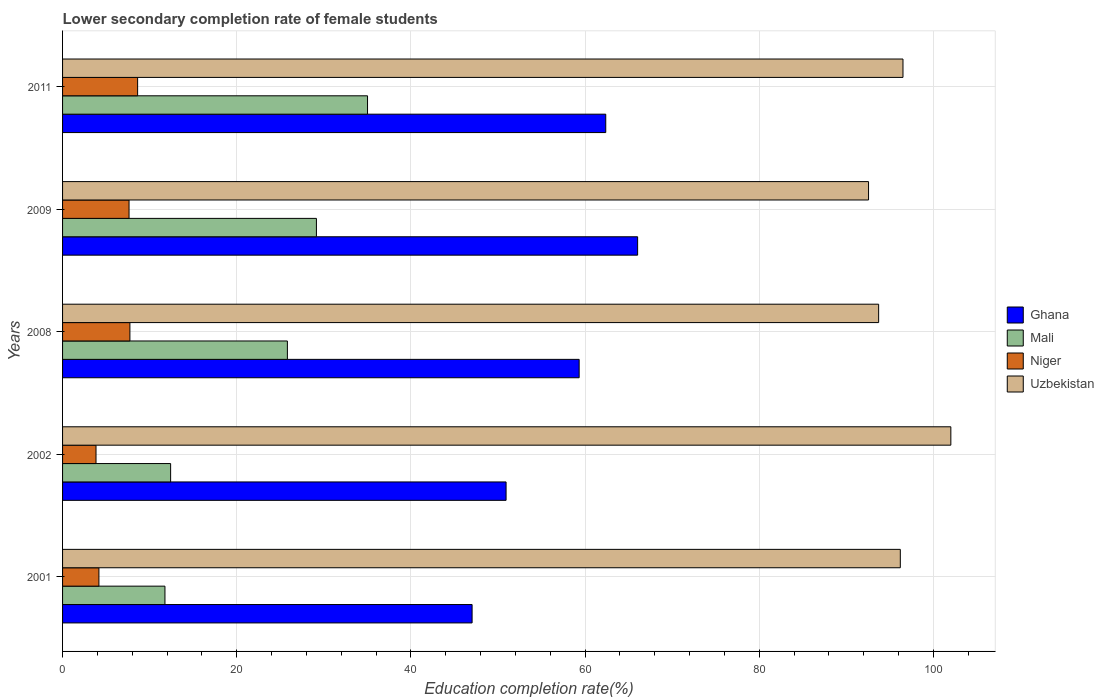How many different coloured bars are there?
Make the answer very short. 4. In how many cases, is the number of bars for a given year not equal to the number of legend labels?
Provide a succinct answer. 0. What is the lower secondary completion rate of female students in Niger in 2002?
Make the answer very short. 3.84. Across all years, what is the maximum lower secondary completion rate of female students in Uzbekistan?
Your answer should be compact. 102. Across all years, what is the minimum lower secondary completion rate of female students in Niger?
Your response must be concise. 3.84. What is the total lower secondary completion rate of female students in Ghana in the graph?
Your answer should be compact. 285.67. What is the difference between the lower secondary completion rate of female students in Ghana in 2009 and that in 2011?
Provide a short and direct response. 3.66. What is the difference between the lower secondary completion rate of female students in Uzbekistan in 2011 and the lower secondary completion rate of female students in Ghana in 2008?
Provide a succinct answer. 37.18. What is the average lower secondary completion rate of female students in Ghana per year?
Offer a very short reply. 57.13. In the year 2009, what is the difference between the lower secondary completion rate of female students in Uzbekistan and lower secondary completion rate of female students in Mali?
Provide a succinct answer. 63.4. In how many years, is the lower secondary completion rate of female students in Uzbekistan greater than 92 %?
Give a very brief answer. 5. What is the ratio of the lower secondary completion rate of female students in Ghana in 2002 to that in 2008?
Your answer should be compact. 0.86. Is the lower secondary completion rate of female students in Niger in 2001 less than that in 2002?
Your response must be concise. No. Is the difference between the lower secondary completion rate of female students in Uzbekistan in 2001 and 2002 greater than the difference between the lower secondary completion rate of female students in Mali in 2001 and 2002?
Make the answer very short. No. What is the difference between the highest and the second highest lower secondary completion rate of female students in Mali?
Give a very brief answer. 5.87. What is the difference between the highest and the lowest lower secondary completion rate of female students in Uzbekistan?
Make the answer very short. 9.45. In how many years, is the lower secondary completion rate of female students in Ghana greater than the average lower secondary completion rate of female students in Ghana taken over all years?
Offer a terse response. 3. Is the sum of the lower secondary completion rate of female students in Mali in 2001 and 2008 greater than the maximum lower secondary completion rate of female students in Uzbekistan across all years?
Offer a very short reply. No. What does the 3rd bar from the top in 2001 represents?
Give a very brief answer. Mali. What does the 2nd bar from the bottom in 2002 represents?
Keep it short and to the point. Mali. How many years are there in the graph?
Give a very brief answer. 5. What is the difference between two consecutive major ticks on the X-axis?
Offer a very short reply. 20. Does the graph contain grids?
Keep it short and to the point. Yes. Where does the legend appear in the graph?
Provide a short and direct response. Center right. What is the title of the graph?
Offer a very short reply. Lower secondary completion rate of female students. Does "Guyana" appear as one of the legend labels in the graph?
Provide a succinct answer. No. What is the label or title of the X-axis?
Keep it short and to the point. Education completion rate(%). What is the Education completion rate(%) in Ghana in 2001?
Give a very brief answer. 47.03. What is the Education completion rate(%) in Mali in 2001?
Offer a very short reply. 11.76. What is the Education completion rate(%) in Niger in 2001?
Offer a very short reply. 4.17. What is the Education completion rate(%) of Uzbekistan in 2001?
Give a very brief answer. 96.2. What is the Education completion rate(%) of Ghana in 2002?
Make the answer very short. 50.93. What is the Education completion rate(%) of Mali in 2002?
Your answer should be very brief. 12.41. What is the Education completion rate(%) of Niger in 2002?
Keep it short and to the point. 3.84. What is the Education completion rate(%) of Uzbekistan in 2002?
Give a very brief answer. 102. What is the Education completion rate(%) in Ghana in 2008?
Your answer should be compact. 59.32. What is the Education completion rate(%) of Mali in 2008?
Your answer should be very brief. 25.82. What is the Education completion rate(%) of Niger in 2008?
Your answer should be very brief. 7.73. What is the Education completion rate(%) of Uzbekistan in 2008?
Keep it short and to the point. 93.71. What is the Education completion rate(%) in Ghana in 2009?
Offer a terse response. 66.03. What is the Education completion rate(%) of Mali in 2009?
Your answer should be very brief. 29.15. What is the Education completion rate(%) of Niger in 2009?
Make the answer very short. 7.63. What is the Education completion rate(%) of Uzbekistan in 2009?
Your answer should be very brief. 92.55. What is the Education completion rate(%) in Ghana in 2011?
Make the answer very short. 62.37. What is the Education completion rate(%) in Mali in 2011?
Give a very brief answer. 35.02. What is the Education completion rate(%) of Niger in 2011?
Keep it short and to the point. 8.62. What is the Education completion rate(%) of Uzbekistan in 2011?
Provide a succinct answer. 96.5. Across all years, what is the maximum Education completion rate(%) in Ghana?
Ensure brevity in your answer.  66.03. Across all years, what is the maximum Education completion rate(%) of Mali?
Your response must be concise. 35.02. Across all years, what is the maximum Education completion rate(%) of Niger?
Your answer should be compact. 8.62. Across all years, what is the maximum Education completion rate(%) in Uzbekistan?
Your answer should be compact. 102. Across all years, what is the minimum Education completion rate(%) of Ghana?
Offer a terse response. 47.03. Across all years, what is the minimum Education completion rate(%) in Mali?
Provide a short and direct response. 11.76. Across all years, what is the minimum Education completion rate(%) in Niger?
Offer a very short reply. 3.84. Across all years, what is the minimum Education completion rate(%) in Uzbekistan?
Ensure brevity in your answer.  92.55. What is the total Education completion rate(%) of Ghana in the graph?
Offer a very short reply. 285.67. What is the total Education completion rate(%) of Mali in the graph?
Offer a terse response. 114.15. What is the total Education completion rate(%) in Niger in the graph?
Make the answer very short. 32. What is the total Education completion rate(%) in Uzbekistan in the graph?
Your answer should be very brief. 480.95. What is the difference between the Education completion rate(%) in Ghana in 2001 and that in 2002?
Your response must be concise. -3.9. What is the difference between the Education completion rate(%) in Mali in 2001 and that in 2002?
Make the answer very short. -0.65. What is the difference between the Education completion rate(%) in Niger in 2001 and that in 2002?
Offer a terse response. 0.33. What is the difference between the Education completion rate(%) in Uzbekistan in 2001 and that in 2002?
Provide a succinct answer. -5.8. What is the difference between the Education completion rate(%) of Ghana in 2001 and that in 2008?
Your response must be concise. -12.29. What is the difference between the Education completion rate(%) in Mali in 2001 and that in 2008?
Offer a terse response. -14.06. What is the difference between the Education completion rate(%) of Niger in 2001 and that in 2008?
Provide a succinct answer. -3.56. What is the difference between the Education completion rate(%) in Uzbekistan in 2001 and that in 2008?
Ensure brevity in your answer.  2.49. What is the difference between the Education completion rate(%) of Ghana in 2001 and that in 2009?
Offer a very short reply. -19.01. What is the difference between the Education completion rate(%) in Mali in 2001 and that in 2009?
Ensure brevity in your answer.  -17.39. What is the difference between the Education completion rate(%) of Niger in 2001 and that in 2009?
Give a very brief answer. -3.46. What is the difference between the Education completion rate(%) of Uzbekistan in 2001 and that in 2009?
Keep it short and to the point. 3.65. What is the difference between the Education completion rate(%) of Ghana in 2001 and that in 2011?
Your answer should be very brief. -15.35. What is the difference between the Education completion rate(%) in Mali in 2001 and that in 2011?
Offer a terse response. -23.26. What is the difference between the Education completion rate(%) in Niger in 2001 and that in 2011?
Offer a terse response. -4.45. What is the difference between the Education completion rate(%) in Uzbekistan in 2001 and that in 2011?
Keep it short and to the point. -0.31. What is the difference between the Education completion rate(%) in Ghana in 2002 and that in 2008?
Provide a short and direct response. -8.39. What is the difference between the Education completion rate(%) of Mali in 2002 and that in 2008?
Provide a short and direct response. -13.41. What is the difference between the Education completion rate(%) in Niger in 2002 and that in 2008?
Keep it short and to the point. -3.89. What is the difference between the Education completion rate(%) of Uzbekistan in 2002 and that in 2008?
Give a very brief answer. 8.29. What is the difference between the Education completion rate(%) of Ghana in 2002 and that in 2009?
Ensure brevity in your answer.  -15.1. What is the difference between the Education completion rate(%) of Mali in 2002 and that in 2009?
Provide a succinct answer. -16.74. What is the difference between the Education completion rate(%) of Niger in 2002 and that in 2009?
Your answer should be compact. -3.79. What is the difference between the Education completion rate(%) of Uzbekistan in 2002 and that in 2009?
Offer a terse response. 9.45. What is the difference between the Education completion rate(%) of Ghana in 2002 and that in 2011?
Your response must be concise. -11.44. What is the difference between the Education completion rate(%) of Mali in 2002 and that in 2011?
Provide a short and direct response. -22.61. What is the difference between the Education completion rate(%) in Niger in 2002 and that in 2011?
Provide a short and direct response. -4.78. What is the difference between the Education completion rate(%) in Uzbekistan in 2002 and that in 2011?
Provide a short and direct response. 5.5. What is the difference between the Education completion rate(%) in Ghana in 2008 and that in 2009?
Keep it short and to the point. -6.71. What is the difference between the Education completion rate(%) in Mali in 2008 and that in 2009?
Provide a short and direct response. -3.33. What is the difference between the Education completion rate(%) in Niger in 2008 and that in 2009?
Your response must be concise. 0.1. What is the difference between the Education completion rate(%) of Uzbekistan in 2008 and that in 2009?
Offer a very short reply. 1.16. What is the difference between the Education completion rate(%) of Ghana in 2008 and that in 2011?
Give a very brief answer. -3.05. What is the difference between the Education completion rate(%) in Mali in 2008 and that in 2011?
Keep it short and to the point. -9.2. What is the difference between the Education completion rate(%) of Niger in 2008 and that in 2011?
Give a very brief answer. -0.89. What is the difference between the Education completion rate(%) of Uzbekistan in 2008 and that in 2011?
Give a very brief answer. -2.79. What is the difference between the Education completion rate(%) of Ghana in 2009 and that in 2011?
Offer a very short reply. 3.66. What is the difference between the Education completion rate(%) of Mali in 2009 and that in 2011?
Make the answer very short. -5.87. What is the difference between the Education completion rate(%) in Niger in 2009 and that in 2011?
Give a very brief answer. -0.99. What is the difference between the Education completion rate(%) of Uzbekistan in 2009 and that in 2011?
Your answer should be compact. -3.95. What is the difference between the Education completion rate(%) of Ghana in 2001 and the Education completion rate(%) of Mali in 2002?
Offer a terse response. 34.62. What is the difference between the Education completion rate(%) in Ghana in 2001 and the Education completion rate(%) in Niger in 2002?
Provide a short and direct response. 43.18. What is the difference between the Education completion rate(%) of Ghana in 2001 and the Education completion rate(%) of Uzbekistan in 2002?
Provide a short and direct response. -54.97. What is the difference between the Education completion rate(%) of Mali in 2001 and the Education completion rate(%) of Niger in 2002?
Your response must be concise. 7.92. What is the difference between the Education completion rate(%) in Mali in 2001 and the Education completion rate(%) in Uzbekistan in 2002?
Your answer should be very brief. -90.24. What is the difference between the Education completion rate(%) in Niger in 2001 and the Education completion rate(%) in Uzbekistan in 2002?
Offer a very short reply. -97.82. What is the difference between the Education completion rate(%) of Ghana in 2001 and the Education completion rate(%) of Mali in 2008?
Your answer should be compact. 21.21. What is the difference between the Education completion rate(%) in Ghana in 2001 and the Education completion rate(%) in Niger in 2008?
Make the answer very short. 39.29. What is the difference between the Education completion rate(%) of Ghana in 2001 and the Education completion rate(%) of Uzbekistan in 2008?
Make the answer very short. -46.68. What is the difference between the Education completion rate(%) of Mali in 2001 and the Education completion rate(%) of Niger in 2008?
Keep it short and to the point. 4.02. What is the difference between the Education completion rate(%) in Mali in 2001 and the Education completion rate(%) in Uzbekistan in 2008?
Your answer should be very brief. -81.95. What is the difference between the Education completion rate(%) of Niger in 2001 and the Education completion rate(%) of Uzbekistan in 2008?
Ensure brevity in your answer.  -89.53. What is the difference between the Education completion rate(%) in Ghana in 2001 and the Education completion rate(%) in Mali in 2009?
Your answer should be very brief. 17.88. What is the difference between the Education completion rate(%) of Ghana in 2001 and the Education completion rate(%) of Niger in 2009?
Offer a very short reply. 39.39. What is the difference between the Education completion rate(%) of Ghana in 2001 and the Education completion rate(%) of Uzbekistan in 2009?
Your response must be concise. -45.52. What is the difference between the Education completion rate(%) in Mali in 2001 and the Education completion rate(%) in Niger in 2009?
Make the answer very short. 4.12. What is the difference between the Education completion rate(%) in Mali in 2001 and the Education completion rate(%) in Uzbekistan in 2009?
Ensure brevity in your answer.  -80.79. What is the difference between the Education completion rate(%) in Niger in 2001 and the Education completion rate(%) in Uzbekistan in 2009?
Make the answer very short. -88.37. What is the difference between the Education completion rate(%) in Ghana in 2001 and the Education completion rate(%) in Mali in 2011?
Make the answer very short. 12.01. What is the difference between the Education completion rate(%) of Ghana in 2001 and the Education completion rate(%) of Niger in 2011?
Your answer should be compact. 38.41. What is the difference between the Education completion rate(%) of Ghana in 2001 and the Education completion rate(%) of Uzbekistan in 2011?
Offer a terse response. -49.48. What is the difference between the Education completion rate(%) of Mali in 2001 and the Education completion rate(%) of Niger in 2011?
Make the answer very short. 3.14. What is the difference between the Education completion rate(%) of Mali in 2001 and the Education completion rate(%) of Uzbekistan in 2011?
Keep it short and to the point. -84.75. What is the difference between the Education completion rate(%) of Niger in 2001 and the Education completion rate(%) of Uzbekistan in 2011?
Your response must be concise. -92.33. What is the difference between the Education completion rate(%) of Ghana in 2002 and the Education completion rate(%) of Mali in 2008?
Provide a succinct answer. 25.11. What is the difference between the Education completion rate(%) of Ghana in 2002 and the Education completion rate(%) of Niger in 2008?
Keep it short and to the point. 43.2. What is the difference between the Education completion rate(%) of Ghana in 2002 and the Education completion rate(%) of Uzbekistan in 2008?
Provide a short and direct response. -42.78. What is the difference between the Education completion rate(%) in Mali in 2002 and the Education completion rate(%) in Niger in 2008?
Ensure brevity in your answer.  4.68. What is the difference between the Education completion rate(%) in Mali in 2002 and the Education completion rate(%) in Uzbekistan in 2008?
Offer a terse response. -81.3. What is the difference between the Education completion rate(%) of Niger in 2002 and the Education completion rate(%) of Uzbekistan in 2008?
Your response must be concise. -89.87. What is the difference between the Education completion rate(%) of Ghana in 2002 and the Education completion rate(%) of Mali in 2009?
Your answer should be compact. 21.78. What is the difference between the Education completion rate(%) in Ghana in 2002 and the Education completion rate(%) in Niger in 2009?
Ensure brevity in your answer.  43.29. What is the difference between the Education completion rate(%) of Ghana in 2002 and the Education completion rate(%) of Uzbekistan in 2009?
Offer a very short reply. -41.62. What is the difference between the Education completion rate(%) of Mali in 2002 and the Education completion rate(%) of Niger in 2009?
Make the answer very short. 4.77. What is the difference between the Education completion rate(%) in Mali in 2002 and the Education completion rate(%) in Uzbekistan in 2009?
Your answer should be very brief. -80.14. What is the difference between the Education completion rate(%) in Niger in 2002 and the Education completion rate(%) in Uzbekistan in 2009?
Offer a very short reply. -88.71. What is the difference between the Education completion rate(%) of Ghana in 2002 and the Education completion rate(%) of Mali in 2011?
Ensure brevity in your answer.  15.91. What is the difference between the Education completion rate(%) in Ghana in 2002 and the Education completion rate(%) in Niger in 2011?
Give a very brief answer. 42.31. What is the difference between the Education completion rate(%) in Ghana in 2002 and the Education completion rate(%) in Uzbekistan in 2011?
Give a very brief answer. -45.57. What is the difference between the Education completion rate(%) of Mali in 2002 and the Education completion rate(%) of Niger in 2011?
Keep it short and to the point. 3.79. What is the difference between the Education completion rate(%) of Mali in 2002 and the Education completion rate(%) of Uzbekistan in 2011?
Give a very brief answer. -84.09. What is the difference between the Education completion rate(%) of Niger in 2002 and the Education completion rate(%) of Uzbekistan in 2011?
Provide a short and direct response. -92.66. What is the difference between the Education completion rate(%) of Ghana in 2008 and the Education completion rate(%) of Mali in 2009?
Offer a very short reply. 30.17. What is the difference between the Education completion rate(%) of Ghana in 2008 and the Education completion rate(%) of Niger in 2009?
Your answer should be very brief. 51.68. What is the difference between the Education completion rate(%) of Ghana in 2008 and the Education completion rate(%) of Uzbekistan in 2009?
Ensure brevity in your answer.  -33.23. What is the difference between the Education completion rate(%) in Mali in 2008 and the Education completion rate(%) in Niger in 2009?
Offer a very short reply. 18.18. What is the difference between the Education completion rate(%) of Mali in 2008 and the Education completion rate(%) of Uzbekistan in 2009?
Provide a succinct answer. -66.73. What is the difference between the Education completion rate(%) of Niger in 2008 and the Education completion rate(%) of Uzbekistan in 2009?
Your answer should be compact. -84.82. What is the difference between the Education completion rate(%) in Ghana in 2008 and the Education completion rate(%) in Mali in 2011?
Make the answer very short. 24.3. What is the difference between the Education completion rate(%) in Ghana in 2008 and the Education completion rate(%) in Niger in 2011?
Ensure brevity in your answer.  50.7. What is the difference between the Education completion rate(%) in Ghana in 2008 and the Education completion rate(%) in Uzbekistan in 2011?
Keep it short and to the point. -37.18. What is the difference between the Education completion rate(%) of Mali in 2008 and the Education completion rate(%) of Niger in 2011?
Your answer should be compact. 17.2. What is the difference between the Education completion rate(%) of Mali in 2008 and the Education completion rate(%) of Uzbekistan in 2011?
Ensure brevity in your answer.  -70.69. What is the difference between the Education completion rate(%) of Niger in 2008 and the Education completion rate(%) of Uzbekistan in 2011?
Give a very brief answer. -88.77. What is the difference between the Education completion rate(%) in Ghana in 2009 and the Education completion rate(%) in Mali in 2011?
Offer a terse response. 31.01. What is the difference between the Education completion rate(%) of Ghana in 2009 and the Education completion rate(%) of Niger in 2011?
Provide a short and direct response. 57.41. What is the difference between the Education completion rate(%) in Ghana in 2009 and the Education completion rate(%) in Uzbekistan in 2011?
Offer a terse response. -30.47. What is the difference between the Education completion rate(%) of Mali in 2009 and the Education completion rate(%) of Niger in 2011?
Make the answer very short. 20.53. What is the difference between the Education completion rate(%) of Mali in 2009 and the Education completion rate(%) of Uzbekistan in 2011?
Ensure brevity in your answer.  -67.35. What is the difference between the Education completion rate(%) in Niger in 2009 and the Education completion rate(%) in Uzbekistan in 2011?
Offer a terse response. -88.87. What is the average Education completion rate(%) of Ghana per year?
Your answer should be compact. 57.13. What is the average Education completion rate(%) of Mali per year?
Provide a succinct answer. 22.83. What is the average Education completion rate(%) in Niger per year?
Offer a very short reply. 6.4. What is the average Education completion rate(%) in Uzbekistan per year?
Provide a short and direct response. 96.19. In the year 2001, what is the difference between the Education completion rate(%) of Ghana and Education completion rate(%) of Mali?
Provide a succinct answer. 35.27. In the year 2001, what is the difference between the Education completion rate(%) of Ghana and Education completion rate(%) of Niger?
Your response must be concise. 42.85. In the year 2001, what is the difference between the Education completion rate(%) in Ghana and Education completion rate(%) in Uzbekistan?
Your response must be concise. -49.17. In the year 2001, what is the difference between the Education completion rate(%) of Mali and Education completion rate(%) of Niger?
Offer a very short reply. 7.58. In the year 2001, what is the difference between the Education completion rate(%) in Mali and Education completion rate(%) in Uzbekistan?
Your answer should be compact. -84.44. In the year 2001, what is the difference between the Education completion rate(%) of Niger and Education completion rate(%) of Uzbekistan?
Your answer should be very brief. -92.02. In the year 2002, what is the difference between the Education completion rate(%) of Ghana and Education completion rate(%) of Mali?
Your response must be concise. 38.52. In the year 2002, what is the difference between the Education completion rate(%) of Ghana and Education completion rate(%) of Niger?
Make the answer very short. 47.09. In the year 2002, what is the difference between the Education completion rate(%) of Ghana and Education completion rate(%) of Uzbekistan?
Provide a succinct answer. -51.07. In the year 2002, what is the difference between the Education completion rate(%) in Mali and Education completion rate(%) in Niger?
Provide a short and direct response. 8.57. In the year 2002, what is the difference between the Education completion rate(%) of Mali and Education completion rate(%) of Uzbekistan?
Provide a succinct answer. -89.59. In the year 2002, what is the difference between the Education completion rate(%) in Niger and Education completion rate(%) in Uzbekistan?
Your response must be concise. -98.16. In the year 2008, what is the difference between the Education completion rate(%) in Ghana and Education completion rate(%) in Mali?
Ensure brevity in your answer.  33.5. In the year 2008, what is the difference between the Education completion rate(%) in Ghana and Education completion rate(%) in Niger?
Your answer should be very brief. 51.59. In the year 2008, what is the difference between the Education completion rate(%) in Ghana and Education completion rate(%) in Uzbekistan?
Your answer should be very brief. -34.39. In the year 2008, what is the difference between the Education completion rate(%) of Mali and Education completion rate(%) of Niger?
Your answer should be very brief. 18.08. In the year 2008, what is the difference between the Education completion rate(%) in Mali and Education completion rate(%) in Uzbekistan?
Provide a short and direct response. -67.89. In the year 2008, what is the difference between the Education completion rate(%) of Niger and Education completion rate(%) of Uzbekistan?
Make the answer very short. -85.98. In the year 2009, what is the difference between the Education completion rate(%) of Ghana and Education completion rate(%) of Mali?
Provide a short and direct response. 36.88. In the year 2009, what is the difference between the Education completion rate(%) in Ghana and Education completion rate(%) in Niger?
Keep it short and to the point. 58.4. In the year 2009, what is the difference between the Education completion rate(%) in Ghana and Education completion rate(%) in Uzbekistan?
Offer a terse response. -26.52. In the year 2009, what is the difference between the Education completion rate(%) in Mali and Education completion rate(%) in Niger?
Offer a terse response. 21.52. In the year 2009, what is the difference between the Education completion rate(%) in Mali and Education completion rate(%) in Uzbekistan?
Provide a short and direct response. -63.4. In the year 2009, what is the difference between the Education completion rate(%) of Niger and Education completion rate(%) of Uzbekistan?
Ensure brevity in your answer.  -84.91. In the year 2011, what is the difference between the Education completion rate(%) in Ghana and Education completion rate(%) in Mali?
Make the answer very short. 27.35. In the year 2011, what is the difference between the Education completion rate(%) of Ghana and Education completion rate(%) of Niger?
Make the answer very short. 53.75. In the year 2011, what is the difference between the Education completion rate(%) of Ghana and Education completion rate(%) of Uzbekistan?
Your response must be concise. -34.13. In the year 2011, what is the difference between the Education completion rate(%) in Mali and Education completion rate(%) in Niger?
Keep it short and to the point. 26.4. In the year 2011, what is the difference between the Education completion rate(%) of Mali and Education completion rate(%) of Uzbekistan?
Provide a short and direct response. -61.48. In the year 2011, what is the difference between the Education completion rate(%) of Niger and Education completion rate(%) of Uzbekistan?
Keep it short and to the point. -87.88. What is the ratio of the Education completion rate(%) in Ghana in 2001 to that in 2002?
Offer a very short reply. 0.92. What is the ratio of the Education completion rate(%) of Mali in 2001 to that in 2002?
Make the answer very short. 0.95. What is the ratio of the Education completion rate(%) of Niger in 2001 to that in 2002?
Make the answer very short. 1.09. What is the ratio of the Education completion rate(%) of Uzbekistan in 2001 to that in 2002?
Your answer should be compact. 0.94. What is the ratio of the Education completion rate(%) in Ghana in 2001 to that in 2008?
Your response must be concise. 0.79. What is the ratio of the Education completion rate(%) of Mali in 2001 to that in 2008?
Make the answer very short. 0.46. What is the ratio of the Education completion rate(%) of Niger in 2001 to that in 2008?
Give a very brief answer. 0.54. What is the ratio of the Education completion rate(%) in Uzbekistan in 2001 to that in 2008?
Offer a terse response. 1.03. What is the ratio of the Education completion rate(%) in Ghana in 2001 to that in 2009?
Give a very brief answer. 0.71. What is the ratio of the Education completion rate(%) in Mali in 2001 to that in 2009?
Keep it short and to the point. 0.4. What is the ratio of the Education completion rate(%) of Niger in 2001 to that in 2009?
Provide a succinct answer. 0.55. What is the ratio of the Education completion rate(%) of Uzbekistan in 2001 to that in 2009?
Your response must be concise. 1.04. What is the ratio of the Education completion rate(%) of Ghana in 2001 to that in 2011?
Your response must be concise. 0.75. What is the ratio of the Education completion rate(%) of Mali in 2001 to that in 2011?
Give a very brief answer. 0.34. What is the ratio of the Education completion rate(%) of Niger in 2001 to that in 2011?
Ensure brevity in your answer.  0.48. What is the ratio of the Education completion rate(%) of Uzbekistan in 2001 to that in 2011?
Offer a terse response. 1. What is the ratio of the Education completion rate(%) in Ghana in 2002 to that in 2008?
Offer a terse response. 0.86. What is the ratio of the Education completion rate(%) of Mali in 2002 to that in 2008?
Provide a short and direct response. 0.48. What is the ratio of the Education completion rate(%) of Niger in 2002 to that in 2008?
Provide a short and direct response. 0.5. What is the ratio of the Education completion rate(%) of Uzbekistan in 2002 to that in 2008?
Your answer should be compact. 1.09. What is the ratio of the Education completion rate(%) of Ghana in 2002 to that in 2009?
Provide a short and direct response. 0.77. What is the ratio of the Education completion rate(%) in Mali in 2002 to that in 2009?
Keep it short and to the point. 0.43. What is the ratio of the Education completion rate(%) of Niger in 2002 to that in 2009?
Your answer should be very brief. 0.5. What is the ratio of the Education completion rate(%) in Uzbekistan in 2002 to that in 2009?
Provide a short and direct response. 1.1. What is the ratio of the Education completion rate(%) of Ghana in 2002 to that in 2011?
Make the answer very short. 0.82. What is the ratio of the Education completion rate(%) in Mali in 2002 to that in 2011?
Provide a short and direct response. 0.35. What is the ratio of the Education completion rate(%) of Niger in 2002 to that in 2011?
Give a very brief answer. 0.45. What is the ratio of the Education completion rate(%) in Uzbekistan in 2002 to that in 2011?
Keep it short and to the point. 1.06. What is the ratio of the Education completion rate(%) of Ghana in 2008 to that in 2009?
Your response must be concise. 0.9. What is the ratio of the Education completion rate(%) in Mali in 2008 to that in 2009?
Offer a very short reply. 0.89. What is the ratio of the Education completion rate(%) of Niger in 2008 to that in 2009?
Your answer should be compact. 1.01. What is the ratio of the Education completion rate(%) of Uzbekistan in 2008 to that in 2009?
Provide a short and direct response. 1.01. What is the ratio of the Education completion rate(%) of Ghana in 2008 to that in 2011?
Offer a very short reply. 0.95. What is the ratio of the Education completion rate(%) of Mali in 2008 to that in 2011?
Offer a very short reply. 0.74. What is the ratio of the Education completion rate(%) of Niger in 2008 to that in 2011?
Your response must be concise. 0.9. What is the ratio of the Education completion rate(%) in Ghana in 2009 to that in 2011?
Provide a succinct answer. 1.06. What is the ratio of the Education completion rate(%) of Mali in 2009 to that in 2011?
Offer a terse response. 0.83. What is the ratio of the Education completion rate(%) of Niger in 2009 to that in 2011?
Provide a short and direct response. 0.89. What is the ratio of the Education completion rate(%) in Uzbekistan in 2009 to that in 2011?
Your answer should be compact. 0.96. What is the difference between the highest and the second highest Education completion rate(%) of Ghana?
Keep it short and to the point. 3.66. What is the difference between the highest and the second highest Education completion rate(%) in Mali?
Provide a short and direct response. 5.87. What is the difference between the highest and the second highest Education completion rate(%) in Niger?
Provide a succinct answer. 0.89. What is the difference between the highest and the second highest Education completion rate(%) of Uzbekistan?
Your response must be concise. 5.5. What is the difference between the highest and the lowest Education completion rate(%) in Ghana?
Keep it short and to the point. 19.01. What is the difference between the highest and the lowest Education completion rate(%) in Mali?
Keep it short and to the point. 23.26. What is the difference between the highest and the lowest Education completion rate(%) of Niger?
Ensure brevity in your answer.  4.78. What is the difference between the highest and the lowest Education completion rate(%) of Uzbekistan?
Ensure brevity in your answer.  9.45. 